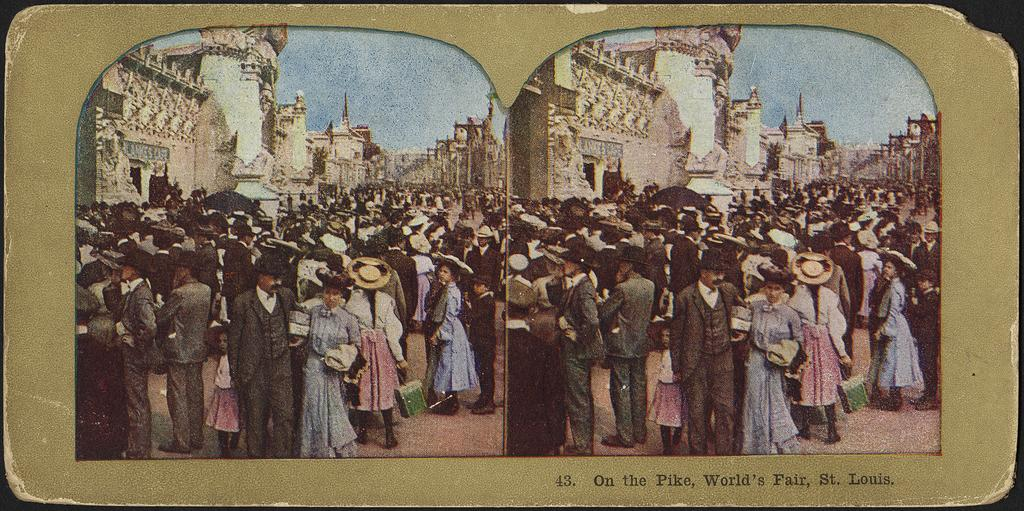<image>
Relay a brief, clear account of the picture shown. Vintage postcard on the Pike at the World's Fair in St. Louis. 